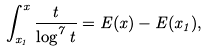<formula> <loc_0><loc_0><loc_500><loc_500>\int _ { x _ { 1 } } ^ { x } \frac { t } { \log ^ { 7 } t } = E ( x ) - E ( x _ { 1 } ) ,</formula> 